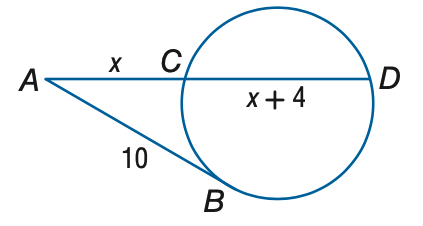Question: A B is tangent to the circle. Find x. Round to the nearest tenth.
Choices:
A. 5.1
B. 6.1
C. 7.1
D. 8.1
Answer with the letter. Answer: B 